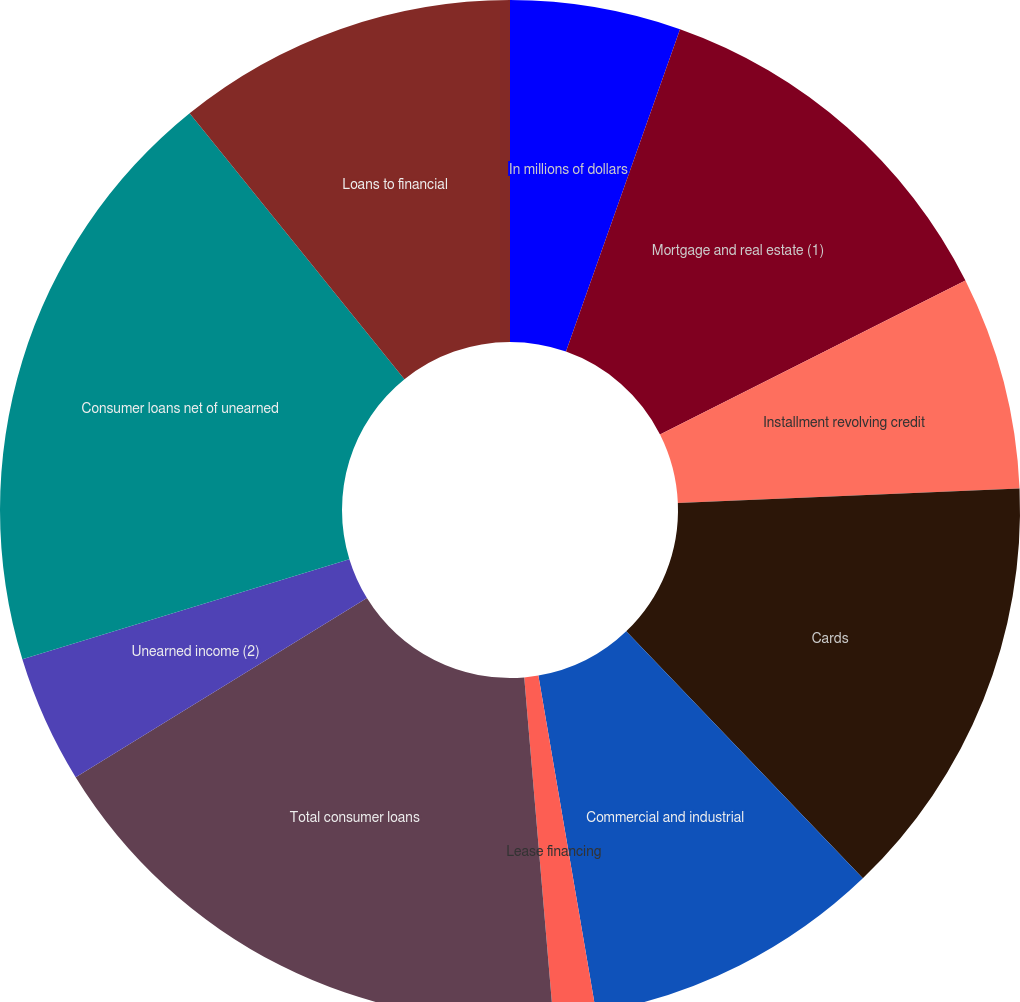Convert chart to OTSL. <chart><loc_0><loc_0><loc_500><loc_500><pie_chart><fcel>In millions of dollars<fcel>Mortgage and real estate (1)<fcel>Installment revolving credit<fcel>Cards<fcel>Commercial and industrial<fcel>Lease financing<fcel>Total consumer loans<fcel>Unearned income (2)<fcel>Consumer loans net of unearned<fcel>Loans to financial<nl><fcel>5.41%<fcel>12.16%<fcel>6.76%<fcel>13.51%<fcel>9.46%<fcel>1.35%<fcel>17.57%<fcel>4.05%<fcel>18.92%<fcel>10.81%<nl></chart> 